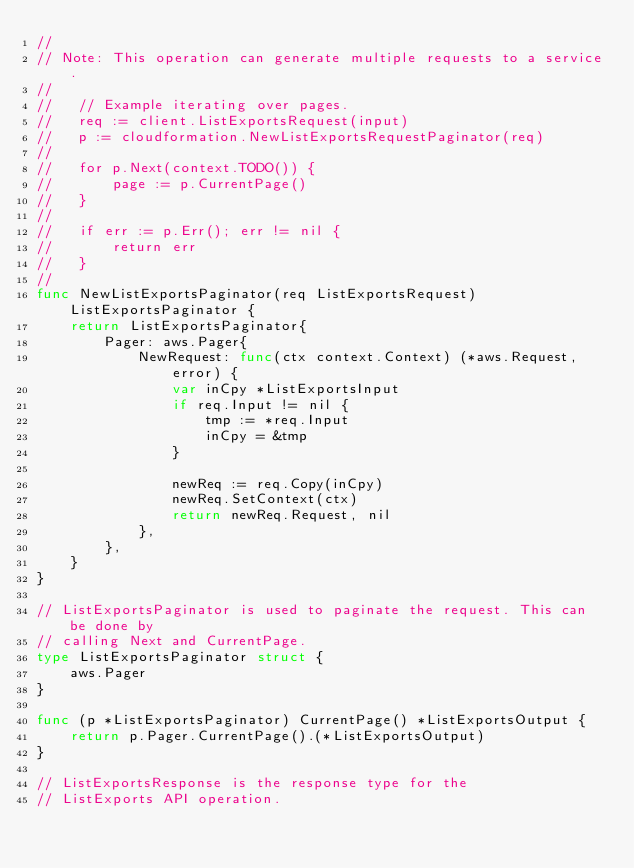<code> <loc_0><loc_0><loc_500><loc_500><_Go_>//
// Note: This operation can generate multiple requests to a service.
//
//   // Example iterating over pages.
//   req := client.ListExportsRequest(input)
//   p := cloudformation.NewListExportsRequestPaginator(req)
//
//   for p.Next(context.TODO()) {
//       page := p.CurrentPage()
//   }
//
//   if err := p.Err(); err != nil {
//       return err
//   }
//
func NewListExportsPaginator(req ListExportsRequest) ListExportsPaginator {
	return ListExportsPaginator{
		Pager: aws.Pager{
			NewRequest: func(ctx context.Context) (*aws.Request, error) {
				var inCpy *ListExportsInput
				if req.Input != nil {
					tmp := *req.Input
					inCpy = &tmp
				}

				newReq := req.Copy(inCpy)
				newReq.SetContext(ctx)
				return newReq.Request, nil
			},
		},
	}
}

// ListExportsPaginator is used to paginate the request. This can be done by
// calling Next and CurrentPage.
type ListExportsPaginator struct {
	aws.Pager
}

func (p *ListExportsPaginator) CurrentPage() *ListExportsOutput {
	return p.Pager.CurrentPage().(*ListExportsOutput)
}

// ListExportsResponse is the response type for the
// ListExports API operation.</code> 